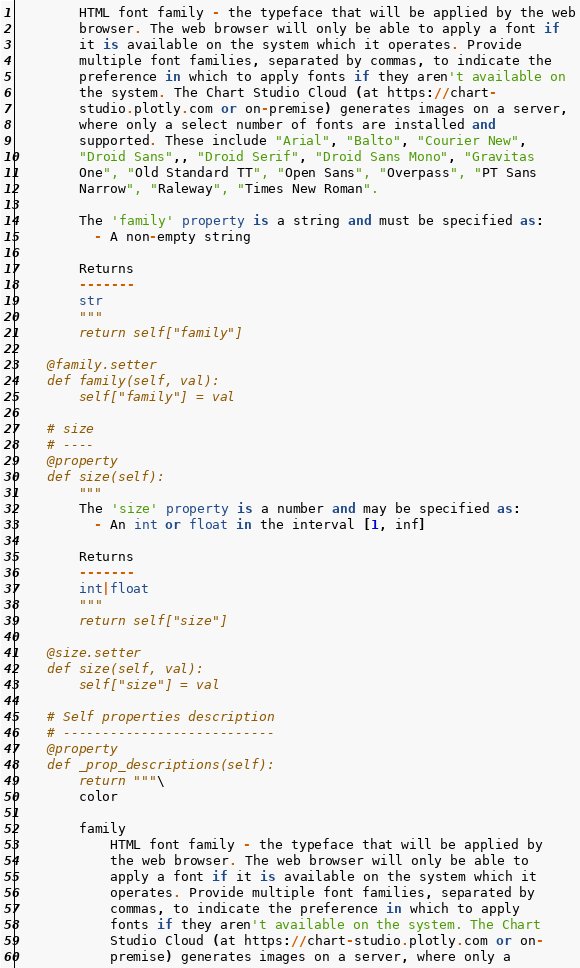<code> <loc_0><loc_0><loc_500><loc_500><_Python_>        HTML font family - the typeface that will be applied by the web
        browser. The web browser will only be able to apply a font if
        it is available on the system which it operates. Provide
        multiple font families, separated by commas, to indicate the
        preference in which to apply fonts if they aren't available on
        the system. The Chart Studio Cloud (at https://chart-
        studio.plotly.com or on-premise) generates images on a server,
        where only a select number of fonts are installed and
        supported. These include "Arial", "Balto", "Courier New",
        "Droid Sans",, "Droid Serif", "Droid Sans Mono", "Gravitas
        One", "Old Standard TT", "Open Sans", "Overpass", "PT Sans
        Narrow", "Raleway", "Times New Roman".

        The 'family' property is a string and must be specified as:
          - A non-empty string

        Returns
        -------
        str
        """
        return self["family"]

    @family.setter
    def family(self, val):
        self["family"] = val

    # size
    # ----
    @property
    def size(self):
        """
        The 'size' property is a number and may be specified as:
          - An int or float in the interval [1, inf]

        Returns
        -------
        int|float
        """
        return self["size"]

    @size.setter
    def size(self, val):
        self["size"] = val

    # Self properties description
    # ---------------------------
    @property
    def _prop_descriptions(self):
        return """\
        color

        family
            HTML font family - the typeface that will be applied by
            the web browser. The web browser will only be able to
            apply a font if it is available on the system which it
            operates. Provide multiple font families, separated by
            commas, to indicate the preference in which to apply
            fonts if they aren't available on the system. The Chart
            Studio Cloud (at https://chart-studio.plotly.com or on-
            premise) generates images on a server, where only a</code> 